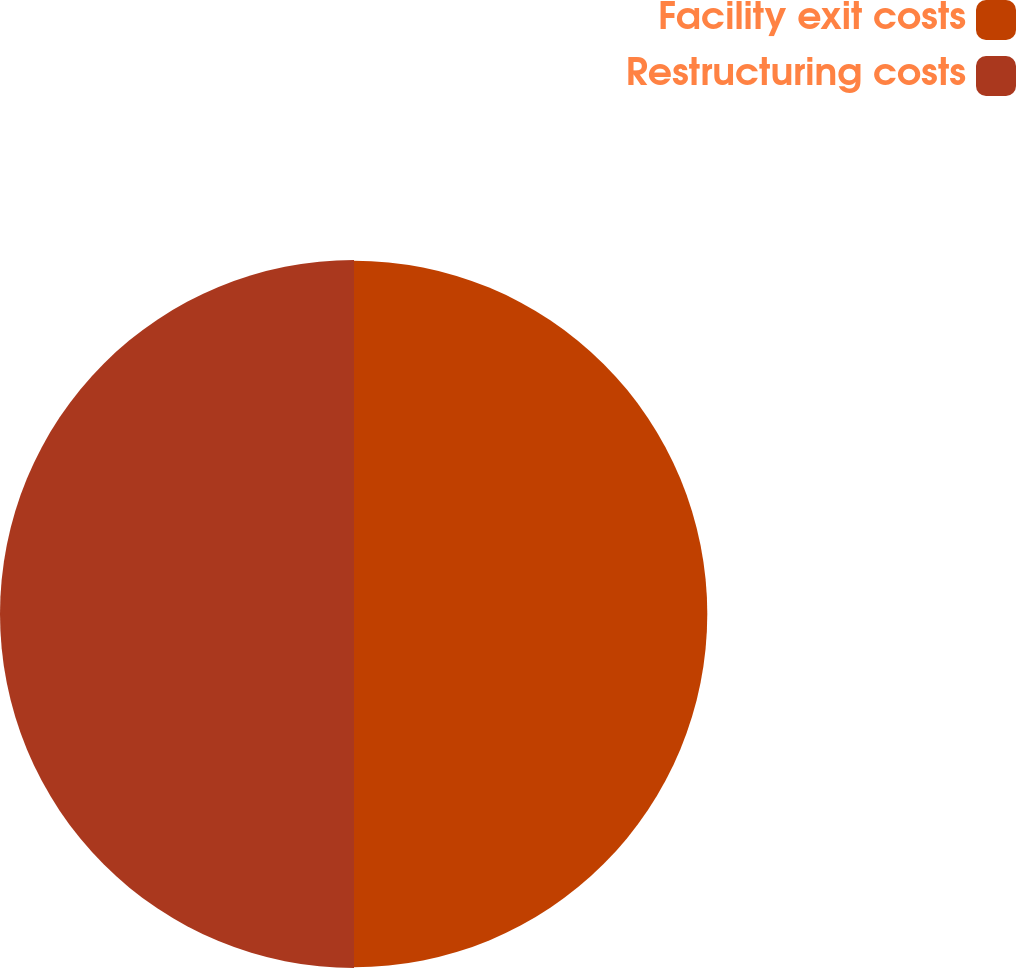<chart> <loc_0><loc_0><loc_500><loc_500><pie_chart><fcel>Facility exit costs<fcel>Restructuring costs<nl><fcel>49.95%<fcel>50.05%<nl></chart> 